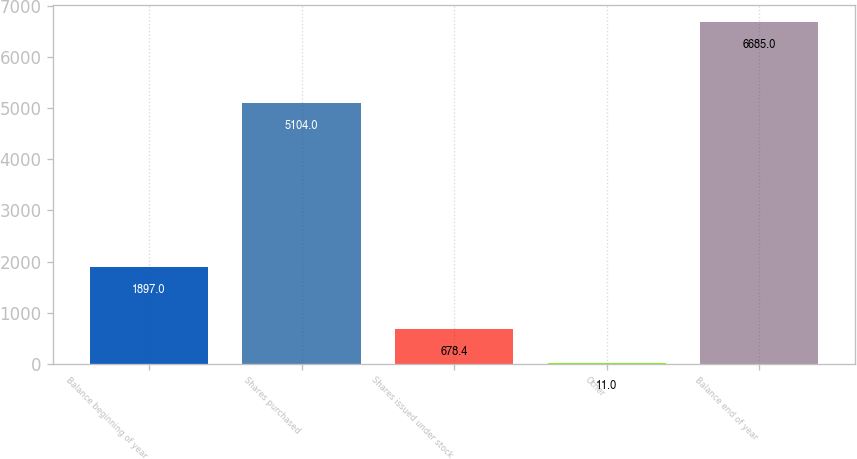Convert chart. <chart><loc_0><loc_0><loc_500><loc_500><bar_chart><fcel>Balance beginning of year<fcel>Shares purchased<fcel>Shares issued under stock<fcel>Other<fcel>Balance end of year<nl><fcel>1897<fcel>5104<fcel>678.4<fcel>11<fcel>6685<nl></chart> 